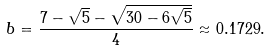<formula> <loc_0><loc_0><loc_500><loc_500>b = \frac { 7 - \sqrt { 5 } - \sqrt { 3 0 - 6 \sqrt { 5 } } } { 4 } \approx 0 . 1 7 2 9 .</formula> 